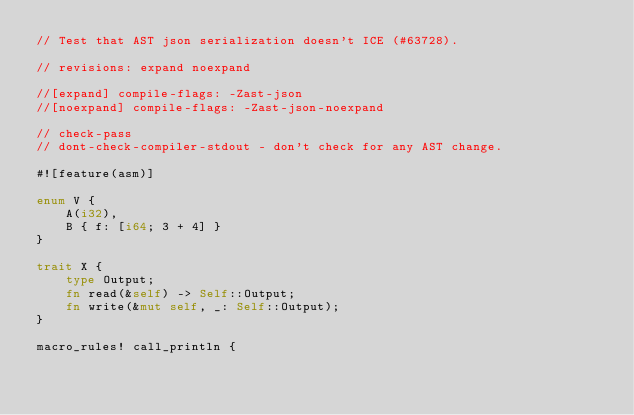Convert code to text. <code><loc_0><loc_0><loc_500><loc_500><_Rust_>// Test that AST json serialization doesn't ICE (#63728).

// revisions: expand noexpand

//[expand] compile-flags: -Zast-json
//[noexpand] compile-flags: -Zast-json-noexpand

// check-pass
// dont-check-compiler-stdout - don't check for any AST change.

#![feature(asm)]

enum V {
    A(i32),
    B { f: [i64; 3 + 4] }
}

trait X {
    type Output;
    fn read(&self) -> Self::Output;
    fn write(&mut self, _: Self::Output);
}

macro_rules! call_println {</code> 